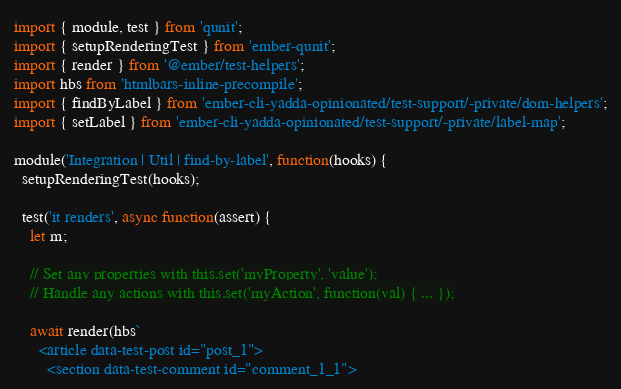<code> <loc_0><loc_0><loc_500><loc_500><_JavaScript_>import { module, test } from 'qunit';
import { setupRenderingTest } from 'ember-qunit';
import { render } from '@ember/test-helpers';
import hbs from 'htmlbars-inline-precompile';
import { findByLabel } from 'ember-cli-yadda-opinionated/test-support/-private/dom-helpers';
import { setLabel } from 'ember-cli-yadda-opinionated/test-support/-private/label-map';

module('Integration | Util | find-by-label', function(hooks) {
  setupRenderingTest(hooks);

  test('it renders', async function(assert) {
    let m;

    // Set any properties with this.set('myProperty', 'value');
    // Handle any actions with this.set('myAction', function(val) { ... });

    await render(hbs`
      <article data-test-post id="post_1">
        <section data-test-comment id="comment_1_1"></code> 